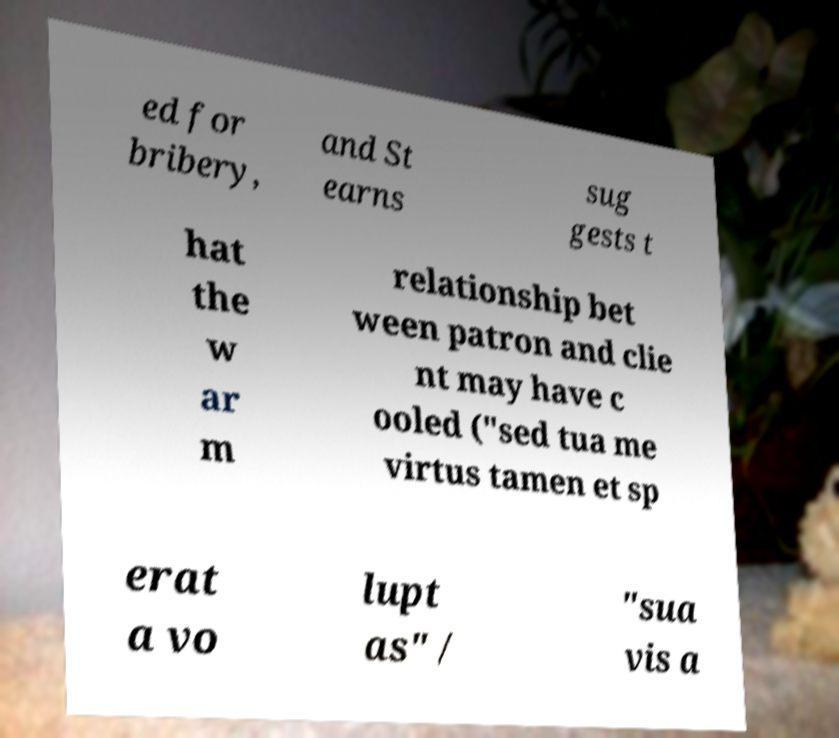For documentation purposes, I need the text within this image transcribed. Could you provide that? ed for bribery, and St earns sug gests t hat the w ar m relationship bet ween patron and clie nt may have c ooled ("sed tua me virtus tamen et sp erat a vo lupt as" / "sua vis a 